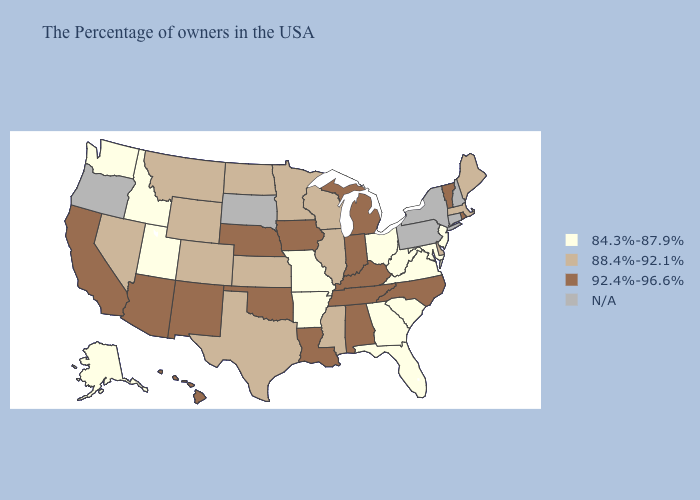Name the states that have a value in the range N/A?
Quick response, please. New Hampshire, Connecticut, New York, Pennsylvania, South Dakota, Oregon. What is the lowest value in the Northeast?
Give a very brief answer. 84.3%-87.9%. Name the states that have a value in the range N/A?
Give a very brief answer. New Hampshire, Connecticut, New York, Pennsylvania, South Dakota, Oregon. Which states have the lowest value in the USA?
Quick response, please. New Jersey, Maryland, Virginia, South Carolina, West Virginia, Ohio, Florida, Georgia, Missouri, Arkansas, Utah, Idaho, Washington, Alaska. Among the states that border South Carolina , which have the lowest value?
Write a very short answer. Georgia. What is the highest value in the USA?
Concise answer only. 92.4%-96.6%. Among the states that border Arkansas , which have the lowest value?
Quick response, please. Missouri. What is the value of New Hampshire?
Keep it brief. N/A. Name the states that have a value in the range 88.4%-92.1%?
Answer briefly. Maine, Massachusetts, Delaware, Wisconsin, Illinois, Mississippi, Minnesota, Kansas, Texas, North Dakota, Wyoming, Colorado, Montana, Nevada. What is the lowest value in the USA?
Keep it brief. 84.3%-87.9%. Name the states that have a value in the range N/A?
Short answer required. New Hampshire, Connecticut, New York, Pennsylvania, South Dakota, Oregon. Name the states that have a value in the range N/A?
Keep it brief. New Hampshire, Connecticut, New York, Pennsylvania, South Dakota, Oregon. Among the states that border West Virginia , which have the highest value?
Give a very brief answer. Kentucky. 